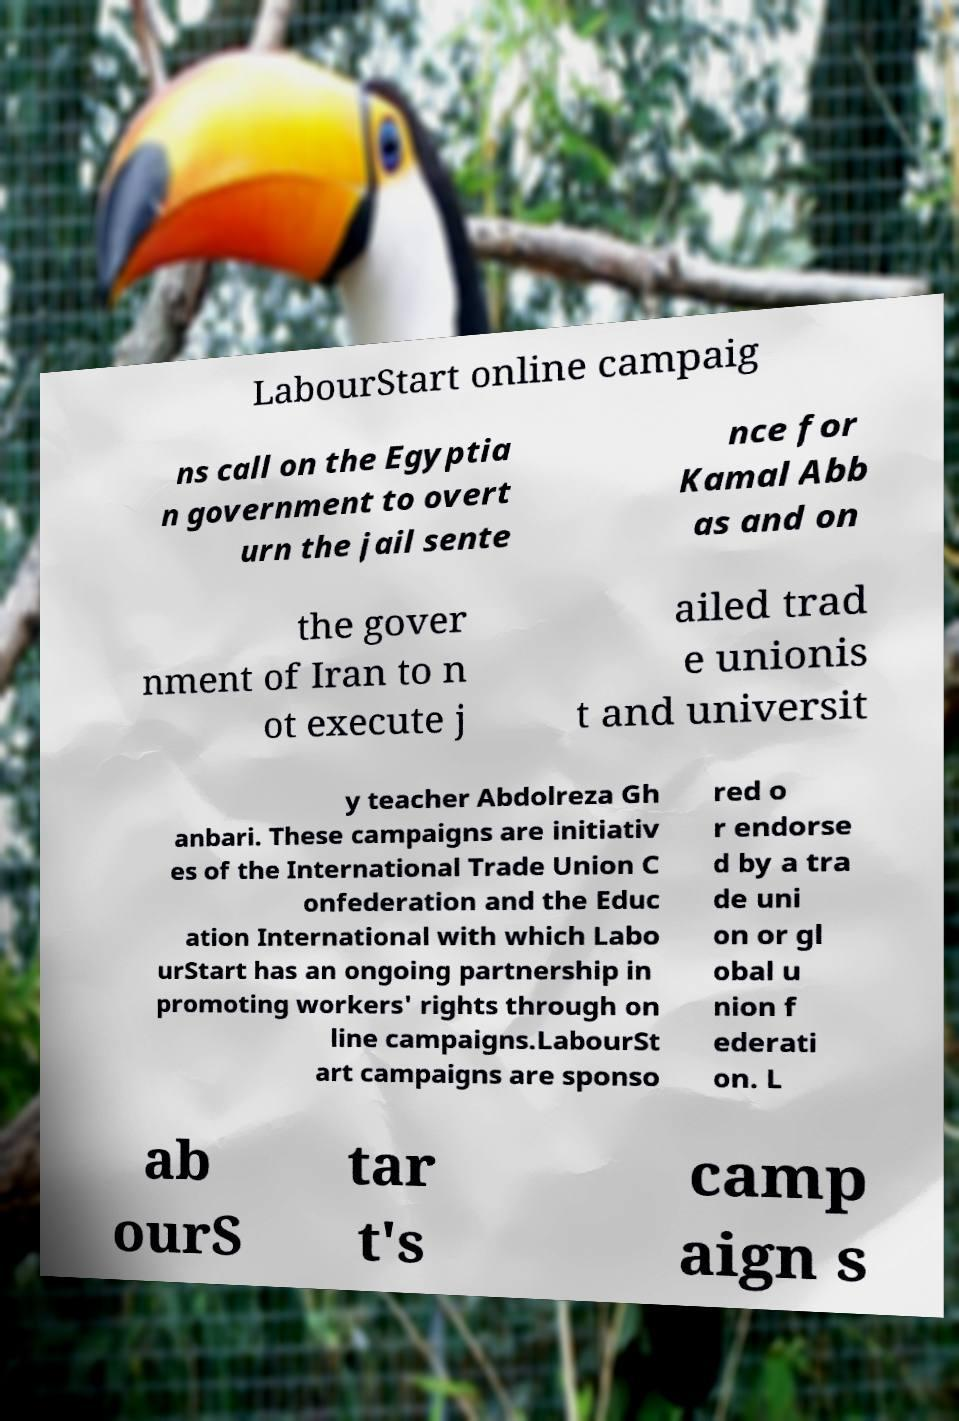Please read and relay the text visible in this image. What does it say? LabourStart online campaig ns call on the Egyptia n government to overt urn the jail sente nce for Kamal Abb as and on the gover nment of Iran to n ot execute j ailed trad e unionis t and universit y teacher Abdolreza Gh anbari. These campaigns are initiativ es of the International Trade Union C onfederation and the Educ ation International with which Labo urStart has an ongoing partnership in promoting workers' rights through on line campaigns.LabourSt art campaigns are sponso red o r endorse d by a tra de uni on or gl obal u nion f ederati on. L ab ourS tar t's camp aign s 